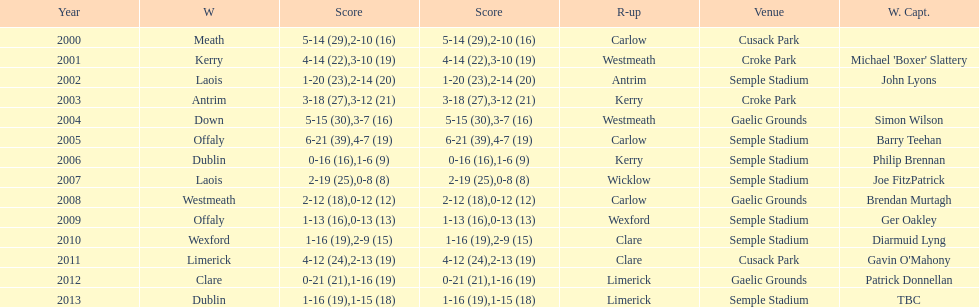What is the difference in the scores in 2000? 13. 